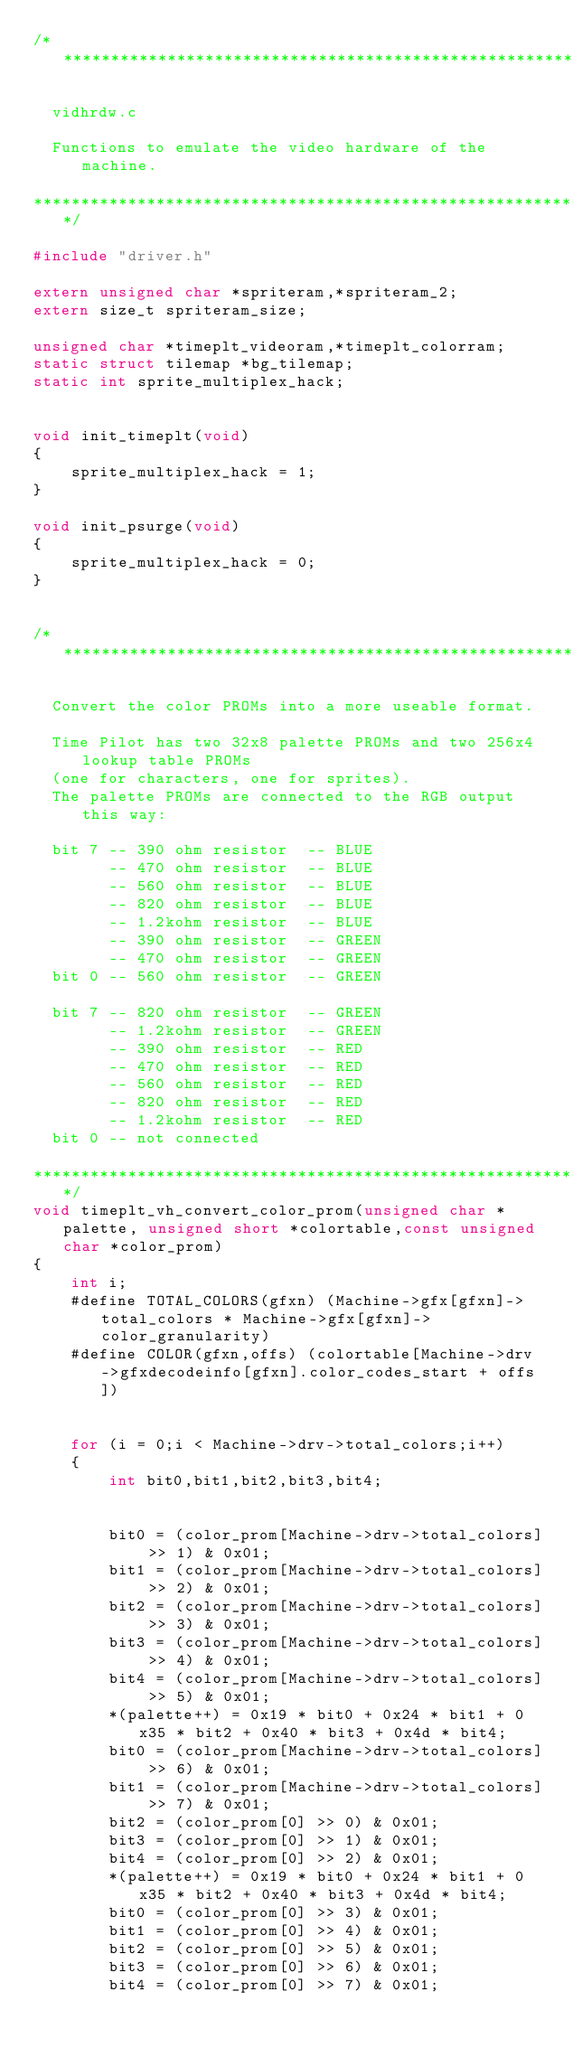Convert code to text. <code><loc_0><loc_0><loc_500><loc_500><_C++_>/***************************************************************************

  vidhrdw.c

  Functions to emulate the video hardware of the machine.

***************************************************************************/

#include "driver.h"

extern unsigned char *spriteram,*spriteram_2;
extern size_t spriteram_size;

unsigned char *timeplt_videoram,*timeplt_colorram;
static struct tilemap *bg_tilemap;
static int sprite_multiplex_hack;


void init_timeplt(void)
{
	sprite_multiplex_hack = 1;
}

void init_psurge(void)
{
	sprite_multiplex_hack = 0;
}


/***************************************************************************

  Convert the color PROMs into a more useable format.

  Time Pilot has two 32x8 palette PROMs and two 256x4 lookup table PROMs
  (one for characters, one for sprites).
  The palette PROMs are connected to the RGB output this way:

  bit 7 -- 390 ohm resistor  -- BLUE
        -- 470 ohm resistor  -- BLUE
        -- 560 ohm resistor  -- BLUE
        -- 820 ohm resistor  -- BLUE
        -- 1.2kohm resistor  -- BLUE
        -- 390 ohm resistor  -- GREEN
        -- 470 ohm resistor  -- GREEN
  bit 0 -- 560 ohm resistor  -- GREEN

  bit 7 -- 820 ohm resistor  -- GREEN
        -- 1.2kohm resistor  -- GREEN
        -- 390 ohm resistor  -- RED
        -- 470 ohm resistor  -- RED
        -- 560 ohm resistor  -- RED
        -- 820 ohm resistor  -- RED
        -- 1.2kohm resistor  -- RED
  bit 0 -- not connected

***************************************************************************/
void timeplt_vh_convert_color_prom(unsigned char *palette, unsigned short *colortable,const unsigned char *color_prom)
{
	int i;
	#define TOTAL_COLORS(gfxn) (Machine->gfx[gfxn]->total_colors * Machine->gfx[gfxn]->color_granularity)
	#define COLOR(gfxn,offs) (colortable[Machine->drv->gfxdecodeinfo[gfxn].color_codes_start + offs])


	for (i = 0;i < Machine->drv->total_colors;i++)
	{
		int bit0,bit1,bit2,bit3,bit4;


		bit0 = (color_prom[Machine->drv->total_colors] >> 1) & 0x01;
		bit1 = (color_prom[Machine->drv->total_colors] >> 2) & 0x01;
		bit2 = (color_prom[Machine->drv->total_colors] >> 3) & 0x01;
		bit3 = (color_prom[Machine->drv->total_colors] >> 4) & 0x01;
		bit4 = (color_prom[Machine->drv->total_colors] >> 5) & 0x01;
		*(palette++) = 0x19 * bit0 + 0x24 * bit1 + 0x35 * bit2 + 0x40 * bit3 + 0x4d * bit4;
		bit0 = (color_prom[Machine->drv->total_colors] >> 6) & 0x01;
		bit1 = (color_prom[Machine->drv->total_colors] >> 7) & 0x01;
		bit2 = (color_prom[0] >> 0) & 0x01;
		bit3 = (color_prom[0] >> 1) & 0x01;
		bit4 = (color_prom[0] >> 2) & 0x01;
		*(palette++) = 0x19 * bit0 + 0x24 * bit1 + 0x35 * bit2 + 0x40 * bit3 + 0x4d * bit4;
		bit0 = (color_prom[0] >> 3) & 0x01;
		bit1 = (color_prom[0] >> 4) & 0x01;
		bit2 = (color_prom[0] >> 5) & 0x01;
		bit3 = (color_prom[0] >> 6) & 0x01;
		bit4 = (color_prom[0] >> 7) & 0x01;</code> 